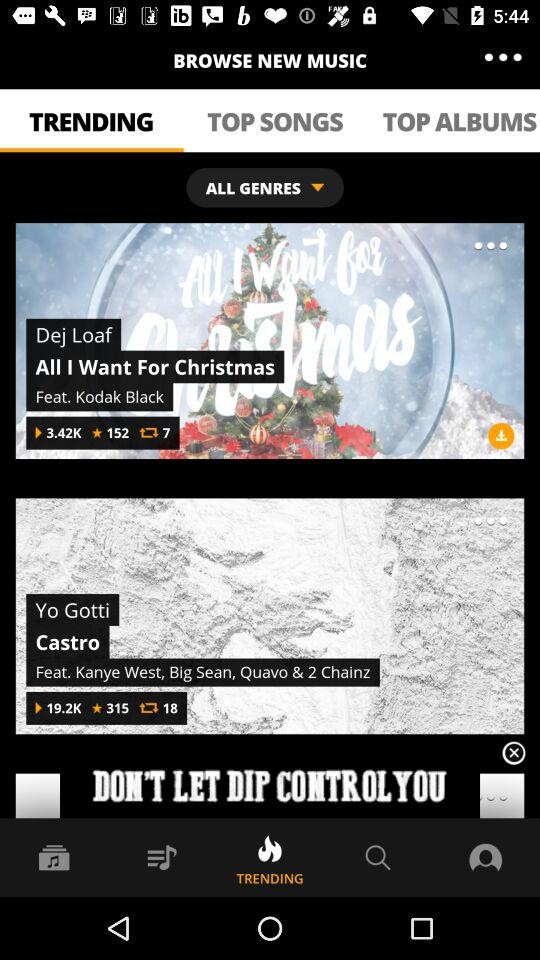How many stars does Castro have? Castro has a total of 315 stars. 